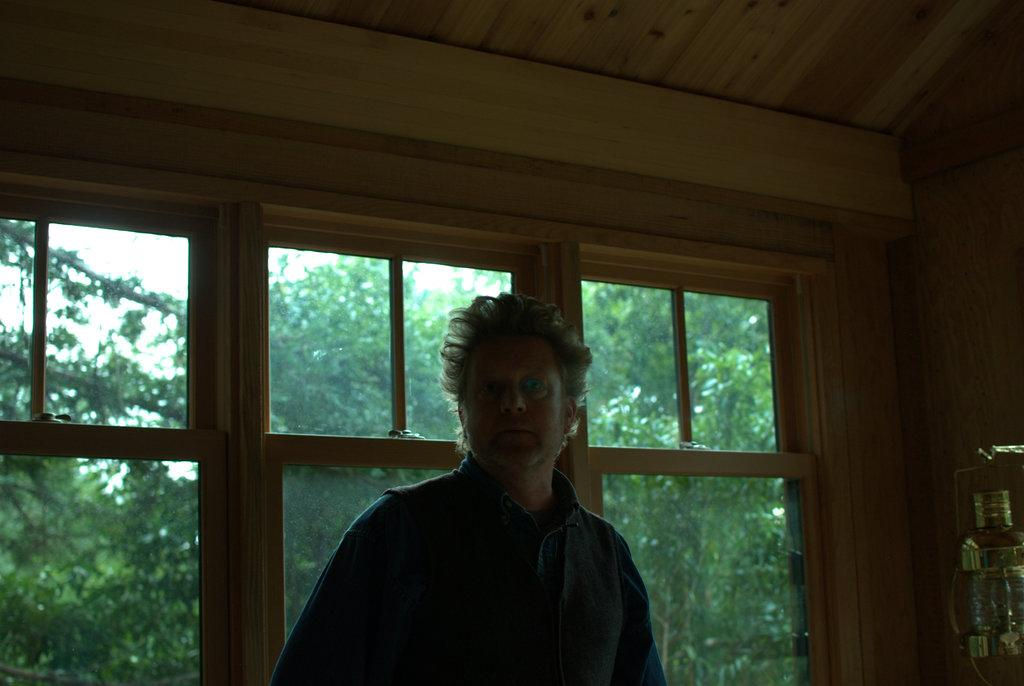What is the main subject of the image? There is a man standing in the image. What is the man wearing? The man is wearing a shirt. What can be seen in the background of the image? There are trees in the background of the image. What object is located on the right side of the image? There is a silver-colored container on the right side of the image. How many stamps does the man have on his shirt in the image? There are no stamps visible on the man's shirt in the image. What edge is the man standing on in the image? The image does not provide information about the edge or any specific location the man is standing on. 